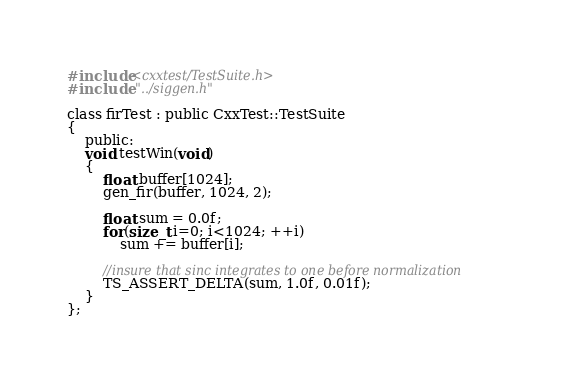Convert code to text. <code><loc_0><loc_0><loc_500><loc_500><_C_>#include<cxxtest/TestSuite.h>
#include "../siggen.h"

class firTest : public CxxTest::TestSuite
{
    public:
    void testWin(void)
    {
        float buffer[1024];
        gen_fir(buffer, 1024, 2);

        float sum = 0.0f;
        for(size_t i=0; i<1024; ++i)
            sum += buffer[i];

        //insure that sinc integrates to one before normalization
        TS_ASSERT_DELTA(sum, 1.0f, 0.01f);
    }
};

</code> 